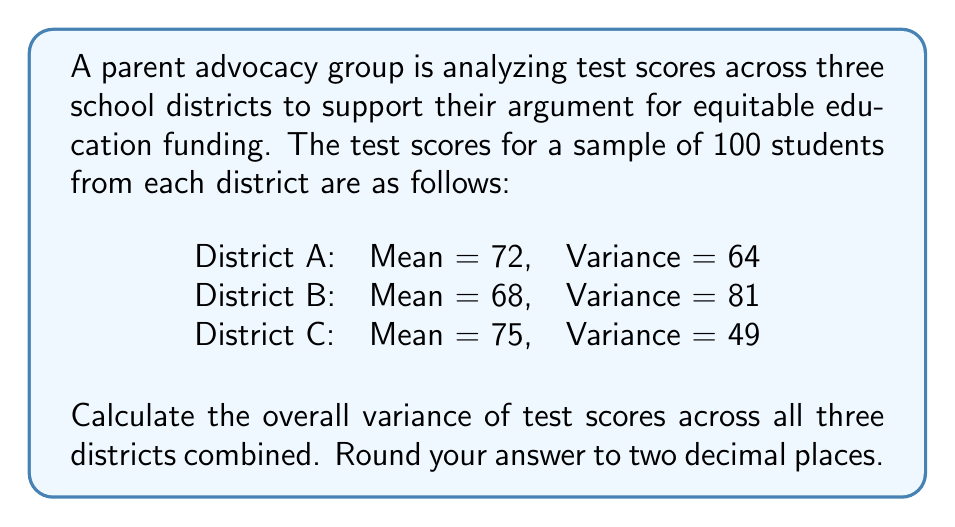Could you help me with this problem? To calculate the overall variance across all three districts, we'll use the formula for the variance of combined populations:

$$\text{Var}(X) = E[(X - \mu)^2] = E[X^2] - \mu^2$$

Where $\mu$ is the overall mean and $E[X^2]$ is the expected value of $X^2$.

Step 1: Calculate the overall mean $\mu$
$$\mu = \frac{72 + 68 + 75}{3} = 71.67$$

Step 2: Calculate $E[X^2]$ for each district
For District A: $E[X^2] = \text{Var}(A) + \text{Mean}(A)^2 = 64 + 72^2 = 5248$
For District B: $E[X^2] = \text{Var}(B) + \text{Mean}(B)^2 = 81 + 68^2 = 4705$
For District C: $E[X^2] = \text{Var}(C) + \text{Mean}(C)^2 = 49 + 75^2 = 5674$

Step 3: Calculate the overall $E[X^2]$
$$E[X^2] = \frac{5248 + 4705 + 5674}{3} = 5209$$

Step 4: Calculate the overall variance
$$\text{Var}(X) = E[X^2] - \mu^2 = 5209 - 71.67^2 = 5209 - 5136.79 = 72.21$$

Therefore, the overall variance of test scores across all three districts is approximately 72.21.
Answer: 72.21 